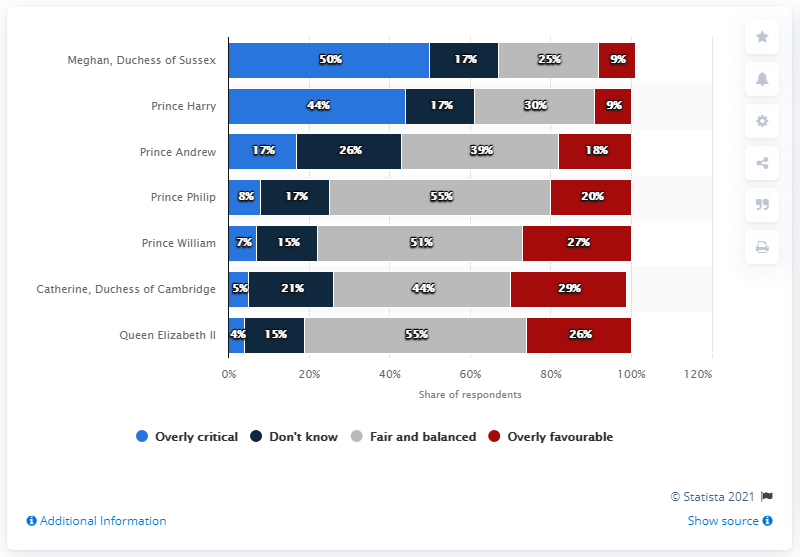Identify some key points in this picture. Before the interview, 50% of British adults believed that Meghan had been subjected to an excessively negative and critical treatment by the media. According to the survey, 44% of British adults believed that Harry and Meghan had received overly critical treatment from the media prior to the interview. It is estimated that 44 people thought that Prince William's media treatment was overly critical. 